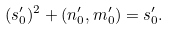Convert formula to latex. <formula><loc_0><loc_0><loc_500><loc_500>( s ^ { \prime } _ { 0 } ) ^ { 2 } + ( n ^ { \prime } _ { 0 } , m ^ { \prime } _ { 0 } ) = s ^ { \prime } _ { 0 } .</formula> 